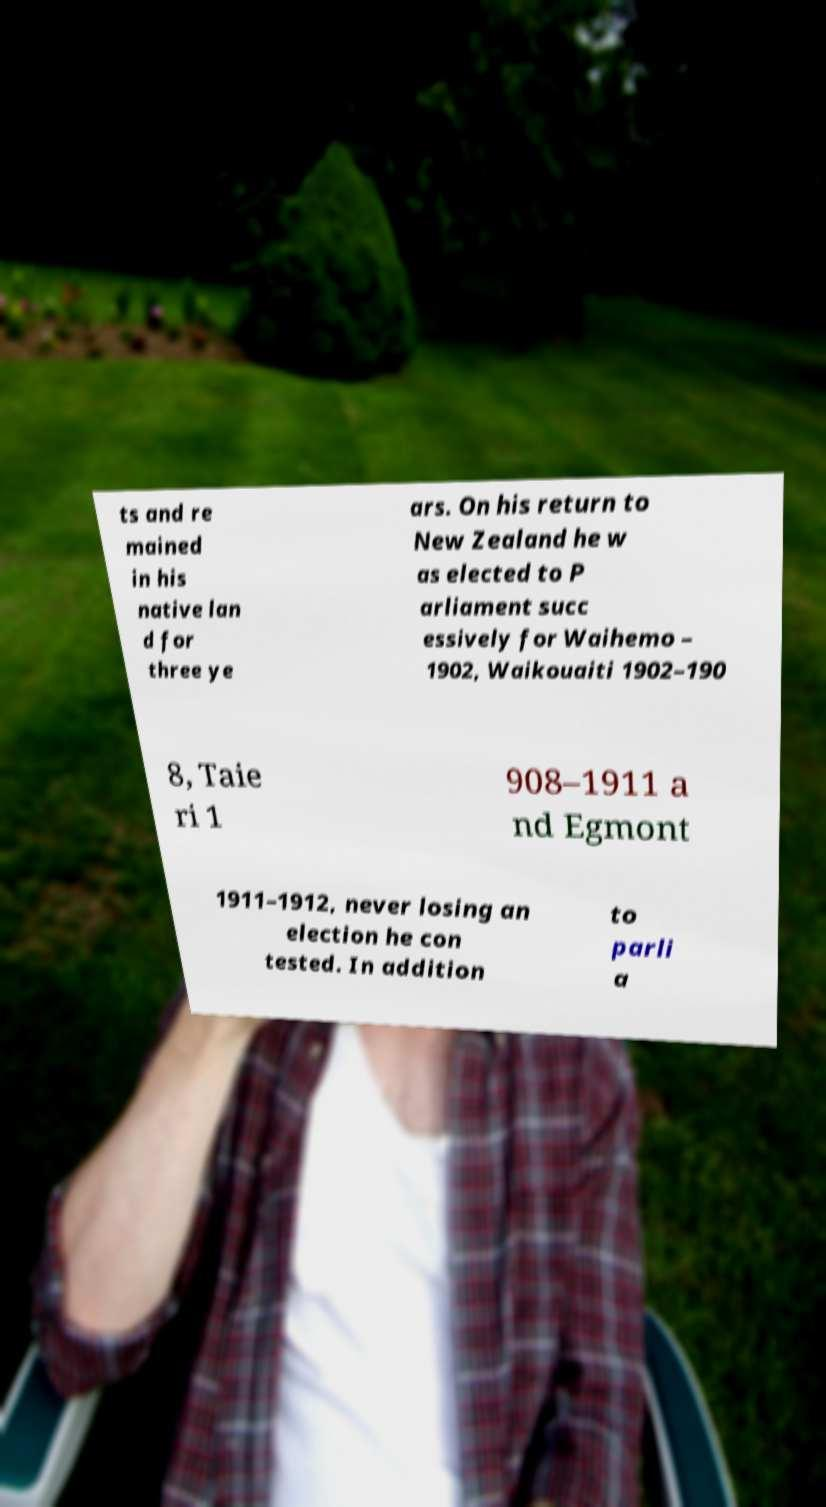Please identify and transcribe the text found in this image. ts and re mained in his native lan d for three ye ars. On his return to New Zealand he w as elected to P arliament succ essively for Waihemo – 1902, Waikouaiti 1902–190 8, Taie ri 1 908–1911 a nd Egmont 1911–1912, never losing an election he con tested. In addition to parli a 